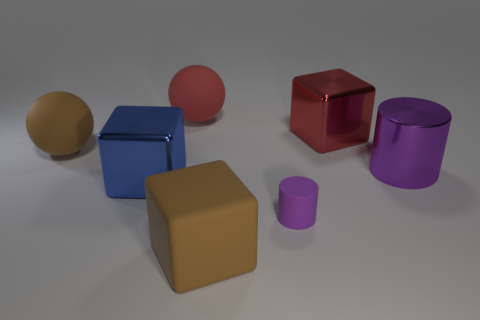What color is the other ball that is the same material as the red ball?
Keep it short and to the point. Brown. What is the big thing in front of the purple object that is on the left side of the red cube made of?
Ensure brevity in your answer.  Rubber. How many things are either cubes that are behind the matte cylinder or metal objects right of the purple matte cylinder?
Provide a short and direct response. 3. There is a red thing that is in front of the large rubber thing behind the large metal cube right of the red matte object; how big is it?
Offer a terse response. Large. Are there an equal number of large shiny blocks in front of the purple rubber thing and brown cubes?
Make the answer very short. No. Are there any other things that have the same shape as the large blue thing?
Provide a short and direct response. Yes. There is a big red rubber thing; is its shape the same as the rubber object that is left of the large red matte ball?
Ensure brevity in your answer.  Yes. The other purple thing that is the same shape as the tiny object is what size?
Ensure brevity in your answer.  Large. What number of other objects are there of the same material as the big blue cube?
Offer a terse response. 2. What is the material of the big brown ball?
Keep it short and to the point. Rubber. 